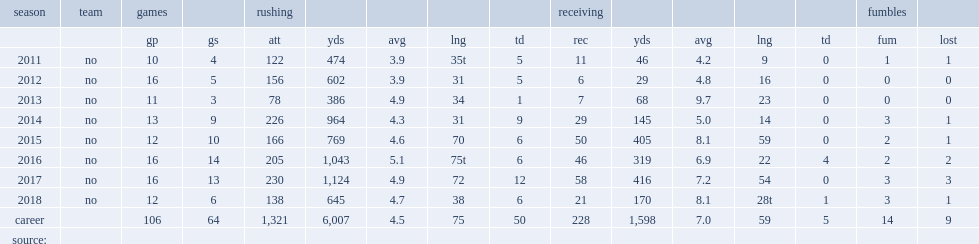How many rushing yards did mark ingram jr. get in 2011? 474.0. 